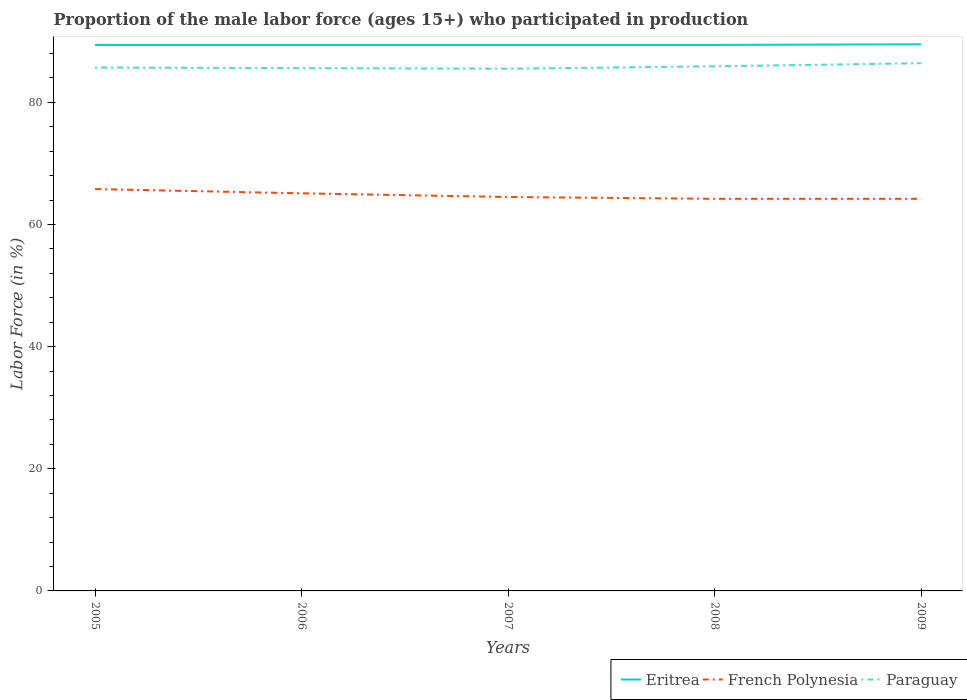Does the line corresponding to Eritrea intersect with the line corresponding to Paraguay?
Ensure brevity in your answer.  No. Across all years, what is the maximum proportion of the male labor force who participated in production in French Polynesia?
Make the answer very short. 64.2. In which year was the proportion of the male labor force who participated in production in French Polynesia maximum?
Give a very brief answer. 2008. What is the total proportion of the male labor force who participated in production in Eritrea in the graph?
Your answer should be compact. -0.1. What is the difference between the highest and the second highest proportion of the male labor force who participated in production in Paraguay?
Offer a terse response. 0.9. Is the proportion of the male labor force who participated in production in French Polynesia strictly greater than the proportion of the male labor force who participated in production in Paraguay over the years?
Offer a very short reply. Yes. How many lines are there?
Your answer should be compact. 3. How many years are there in the graph?
Your answer should be very brief. 5. What is the difference between two consecutive major ticks on the Y-axis?
Make the answer very short. 20. Are the values on the major ticks of Y-axis written in scientific E-notation?
Your answer should be compact. No. Does the graph contain grids?
Keep it short and to the point. No. How many legend labels are there?
Make the answer very short. 3. What is the title of the graph?
Ensure brevity in your answer.  Proportion of the male labor force (ages 15+) who participated in production. Does "Honduras" appear as one of the legend labels in the graph?
Your answer should be very brief. No. What is the label or title of the Y-axis?
Provide a short and direct response. Labor Force (in %). What is the Labor Force (in %) of Eritrea in 2005?
Offer a very short reply. 89.4. What is the Labor Force (in %) in French Polynesia in 2005?
Make the answer very short. 65.8. What is the Labor Force (in %) in Paraguay in 2005?
Your answer should be very brief. 85.7. What is the Labor Force (in %) of Eritrea in 2006?
Your answer should be compact. 89.4. What is the Labor Force (in %) of French Polynesia in 2006?
Your response must be concise. 65.1. What is the Labor Force (in %) in Paraguay in 2006?
Provide a succinct answer. 85.6. What is the Labor Force (in %) in Eritrea in 2007?
Keep it short and to the point. 89.4. What is the Labor Force (in %) in French Polynesia in 2007?
Your answer should be compact. 64.5. What is the Labor Force (in %) of Paraguay in 2007?
Your response must be concise. 85.5. What is the Labor Force (in %) in Eritrea in 2008?
Your answer should be very brief. 89.4. What is the Labor Force (in %) of French Polynesia in 2008?
Keep it short and to the point. 64.2. What is the Labor Force (in %) of Paraguay in 2008?
Keep it short and to the point. 85.9. What is the Labor Force (in %) in Eritrea in 2009?
Keep it short and to the point. 89.5. What is the Labor Force (in %) in French Polynesia in 2009?
Keep it short and to the point. 64.2. What is the Labor Force (in %) in Paraguay in 2009?
Provide a succinct answer. 86.4. Across all years, what is the maximum Labor Force (in %) in Eritrea?
Keep it short and to the point. 89.5. Across all years, what is the maximum Labor Force (in %) in French Polynesia?
Your answer should be very brief. 65.8. Across all years, what is the maximum Labor Force (in %) in Paraguay?
Keep it short and to the point. 86.4. Across all years, what is the minimum Labor Force (in %) in Eritrea?
Offer a terse response. 89.4. Across all years, what is the minimum Labor Force (in %) in French Polynesia?
Your answer should be very brief. 64.2. Across all years, what is the minimum Labor Force (in %) in Paraguay?
Your answer should be very brief. 85.5. What is the total Labor Force (in %) of Eritrea in the graph?
Keep it short and to the point. 447.1. What is the total Labor Force (in %) of French Polynesia in the graph?
Provide a succinct answer. 323.8. What is the total Labor Force (in %) in Paraguay in the graph?
Provide a succinct answer. 429.1. What is the difference between the Labor Force (in %) of Eritrea in 2005 and that in 2006?
Keep it short and to the point. 0. What is the difference between the Labor Force (in %) of Eritrea in 2005 and that in 2007?
Your response must be concise. 0. What is the difference between the Labor Force (in %) of Paraguay in 2005 and that in 2007?
Your answer should be very brief. 0.2. What is the difference between the Labor Force (in %) in French Polynesia in 2005 and that in 2008?
Your answer should be very brief. 1.6. What is the difference between the Labor Force (in %) of Paraguay in 2005 and that in 2009?
Offer a terse response. -0.7. What is the difference between the Labor Force (in %) of Paraguay in 2006 and that in 2007?
Offer a very short reply. 0.1. What is the difference between the Labor Force (in %) of French Polynesia in 2006 and that in 2008?
Offer a terse response. 0.9. What is the difference between the Labor Force (in %) of Paraguay in 2006 and that in 2008?
Make the answer very short. -0.3. What is the difference between the Labor Force (in %) in French Polynesia in 2006 and that in 2009?
Make the answer very short. 0.9. What is the difference between the Labor Force (in %) in Paraguay in 2006 and that in 2009?
Make the answer very short. -0.8. What is the difference between the Labor Force (in %) of Eritrea in 2007 and that in 2008?
Ensure brevity in your answer.  0. What is the difference between the Labor Force (in %) in French Polynesia in 2007 and that in 2008?
Offer a very short reply. 0.3. What is the difference between the Labor Force (in %) in Paraguay in 2007 and that in 2008?
Give a very brief answer. -0.4. What is the difference between the Labor Force (in %) in Eritrea in 2007 and that in 2009?
Ensure brevity in your answer.  -0.1. What is the difference between the Labor Force (in %) in Eritrea in 2008 and that in 2009?
Offer a very short reply. -0.1. What is the difference between the Labor Force (in %) in French Polynesia in 2008 and that in 2009?
Your answer should be very brief. 0. What is the difference between the Labor Force (in %) in Paraguay in 2008 and that in 2009?
Give a very brief answer. -0.5. What is the difference between the Labor Force (in %) of Eritrea in 2005 and the Labor Force (in %) of French Polynesia in 2006?
Your answer should be very brief. 24.3. What is the difference between the Labor Force (in %) in Eritrea in 2005 and the Labor Force (in %) in Paraguay in 2006?
Your answer should be compact. 3.8. What is the difference between the Labor Force (in %) in French Polynesia in 2005 and the Labor Force (in %) in Paraguay in 2006?
Offer a terse response. -19.8. What is the difference between the Labor Force (in %) in Eritrea in 2005 and the Labor Force (in %) in French Polynesia in 2007?
Provide a succinct answer. 24.9. What is the difference between the Labor Force (in %) in French Polynesia in 2005 and the Labor Force (in %) in Paraguay in 2007?
Your answer should be very brief. -19.7. What is the difference between the Labor Force (in %) of Eritrea in 2005 and the Labor Force (in %) of French Polynesia in 2008?
Offer a very short reply. 25.2. What is the difference between the Labor Force (in %) of Eritrea in 2005 and the Labor Force (in %) of Paraguay in 2008?
Ensure brevity in your answer.  3.5. What is the difference between the Labor Force (in %) of French Polynesia in 2005 and the Labor Force (in %) of Paraguay in 2008?
Offer a very short reply. -20.1. What is the difference between the Labor Force (in %) in Eritrea in 2005 and the Labor Force (in %) in French Polynesia in 2009?
Make the answer very short. 25.2. What is the difference between the Labor Force (in %) in French Polynesia in 2005 and the Labor Force (in %) in Paraguay in 2009?
Offer a terse response. -20.6. What is the difference between the Labor Force (in %) of Eritrea in 2006 and the Labor Force (in %) of French Polynesia in 2007?
Offer a very short reply. 24.9. What is the difference between the Labor Force (in %) in French Polynesia in 2006 and the Labor Force (in %) in Paraguay in 2007?
Provide a short and direct response. -20.4. What is the difference between the Labor Force (in %) in Eritrea in 2006 and the Labor Force (in %) in French Polynesia in 2008?
Your answer should be compact. 25.2. What is the difference between the Labor Force (in %) of French Polynesia in 2006 and the Labor Force (in %) of Paraguay in 2008?
Your answer should be very brief. -20.8. What is the difference between the Labor Force (in %) in Eritrea in 2006 and the Labor Force (in %) in French Polynesia in 2009?
Your answer should be very brief. 25.2. What is the difference between the Labor Force (in %) in Eritrea in 2006 and the Labor Force (in %) in Paraguay in 2009?
Offer a terse response. 3. What is the difference between the Labor Force (in %) of French Polynesia in 2006 and the Labor Force (in %) of Paraguay in 2009?
Your answer should be compact. -21.3. What is the difference between the Labor Force (in %) in Eritrea in 2007 and the Labor Force (in %) in French Polynesia in 2008?
Make the answer very short. 25.2. What is the difference between the Labor Force (in %) of French Polynesia in 2007 and the Labor Force (in %) of Paraguay in 2008?
Your answer should be compact. -21.4. What is the difference between the Labor Force (in %) of Eritrea in 2007 and the Labor Force (in %) of French Polynesia in 2009?
Offer a very short reply. 25.2. What is the difference between the Labor Force (in %) of Eritrea in 2007 and the Labor Force (in %) of Paraguay in 2009?
Your answer should be compact. 3. What is the difference between the Labor Force (in %) of French Polynesia in 2007 and the Labor Force (in %) of Paraguay in 2009?
Offer a very short reply. -21.9. What is the difference between the Labor Force (in %) in Eritrea in 2008 and the Labor Force (in %) in French Polynesia in 2009?
Ensure brevity in your answer.  25.2. What is the difference between the Labor Force (in %) of French Polynesia in 2008 and the Labor Force (in %) of Paraguay in 2009?
Provide a short and direct response. -22.2. What is the average Labor Force (in %) in Eritrea per year?
Make the answer very short. 89.42. What is the average Labor Force (in %) of French Polynesia per year?
Provide a succinct answer. 64.76. What is the average Labor Force (in %) of Paraguay per year?
Keep it short and to the point. 85.82. In the year 2005, what is the difference between the Labor Force (in %) in Eritrea and Labor Force (in %) in French Polynesia?
Offer a very short reply. 23.6. In the year 2005, what is the difference between the Labor Force (in %) of Eritrea and Labor Force (in %) of Paraguay?
Your answer should be compact. 3.7. In the year 2005, what is the difference between the Labor Force (in %) of French Polynesia and Labor Force (in %) of Paraguay?
Your response must be concise. -19.9. In the year 2006, what is the difference between the Labor Force (in %) of Eritrea and Labor Force (in %) of French Polynesia?
Give a very brief answer. 24.3. In the year 2006, what is the difference between the Labor Force (in %) in French Polynesia and Labor Force (in %) in Paraguay?
Keep it short and to the point. -20.5. In the year 2007, what is the difference between the Labor Force (in %) of Eritrea and Labor Force (in %) of French Polynesia?
Offer a terse response. 24.9. In the year 2008, what is the difference between the Labor Force (in %) of Eritrea and Labor Force (in %) of French Polynesia?
Offer a terse response. 25.2. In the year 2008, what is the difference between the Labor Force (in %) of Eritrea and Labor Force (in %) of Paraguay?
Your response must be concise. 3.5. In the year 2008, what is the difference between the Labor Force (in %) in French Polynesia and Labor Force (in %) in Paraguay?
Give a very brief answer. -21.7. In the year 2009, what is the difference between the Labor Force (in %) of Eritrea and Labor Force (in %) of French Polynesia?
Your answer should be very brief. 25.3. In the year 2009, what is the difference between the Labor Force (in %) of Eritrea and Labor Force (in %) of Paraguay?
Ensure brevity in your answer.  3.1. In the year 2009, what is the difference between the Labor Force (in %) in French Polynesia and Labor Force (in %) in Paraguay?
Provide a succinct answer. -22.2. What is the ratio of the Labor Force (in %) of Eritrea in 2005 to that in 2006?
Provide a short and direct response. 1. What is the ratio of the Labor Force (in %) in French Polynesia in 2005 to that in 2006?
Ensure brevity in your answer.  1.01. What is the ratio of the Labor Force (in %) of Paraguay in 2005 to that in 2006?
Provide a succinct answer. 1. What is the ratio of the Labor Force (in %) of French Polynesia in 2005 to that in 2007?
Give a very brief answer. 1.02. What is the ratio of the Labor Force (in %) in Paraguay in 2005 to that in 2007?
Offer a very short reply. 1. What is the ratio of the Labor Force (in %) in Eritrea in 2005 to that in 2008?
Ensure brevity in your answer.  1. What is the ratio of the Labor Force (in %) in French Polynesia in 2005 to that in 2008?
Keep it short and to the point. 1.02. What is the ratio of the Labor Force (in %) of Eritrea in 2005 to that in 2009?
Ensure brevity in your answer.  1. What is the ratio of the Labor Force (in %) in French Polynesia in 2005 to that in 2009?
Offer a terse response. 1.02. What is the ratio of the Labor Force (in %) of Paraguay in 2005 to that in 2009?
Make the answer very short. 0.99. What is the ratio of the Labor Force (in %) of French Polynesia in 2006 to that in 2007?
Make the answer very short. 1.01. What is the ratio of the Labor Force (in %) of Paraguay in 2006 to that in 2007?
Provide a short and direct response. 1. What is the ratio of the Labor Force (in %) in French Polynesia in 2006 to that in 2008?
Your answer should be very brief. 1.01. What is the ratio of the Labor Force (in %) of Eritrea in 2006 to that in 2009?
Ensure brevity in your answer.  1. What is the ratio of the Labor Force (in %) in French Polynesia in 2007 to that in 2009?
Your answer should be very brief. 1. What is the ratio of the Labor Force (in %) of Paraguay in 2007 to that in 2009?
Offer a terse response. 0.99. What is the difference between the highest and the second highest Labor Force (in %) of Eritrea?
Offer a very short reply. 0.1. What is the difference between the highest and the second highest Labor Force (in %) in Paraguay?
Offer a very short reply. 0.5. What is the difference between the highest and the lowest Labor Force (in %) in Paraguay?
Ensure brevity in your answer.  0.9. 